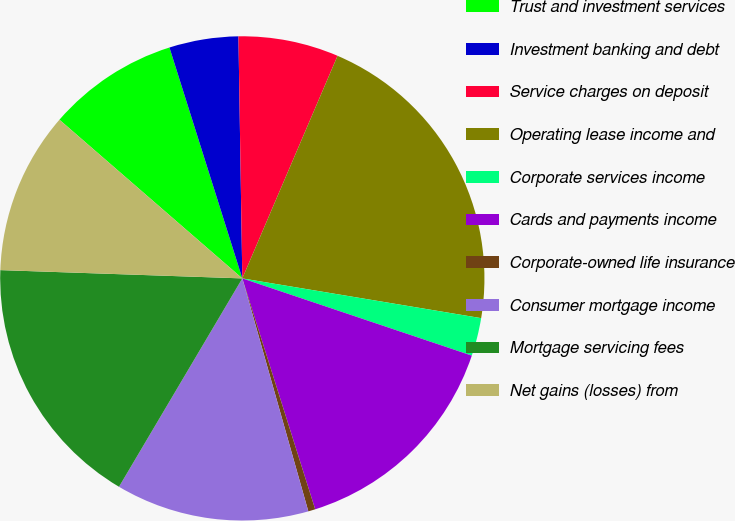Convert chart to OTSL. <chart><loc_0><loc_0><loc_500><loc_500><pie_chart><fcel>Trust and investment services<fcel>Investment banking and debt<fcel>Service charges on deposit<fcel>Operating lease income and<fcel>Corporate services income<fcel>Cards and payments income<fcel>Corporate-owned life insurance<fcel>Consumer mortgage income<fcel>Mortgage servicing fees<fcel>Net gains (losses) from<nl><fcel>8.76%<fcel>4.61%<fcel>6.69%<fcel>21.19%<fcel>2.54%<fcel>14.97%<fcel>0.47%<fcel>12.9%<fcel>17.04%<fcel>10.83%<nl></chart> 